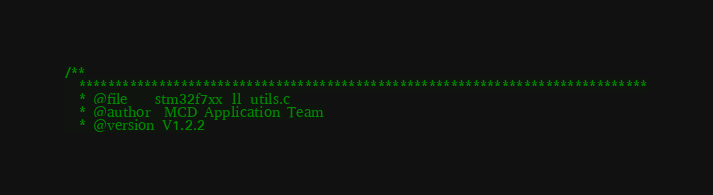Convert code to text. <code><loc_0><loc_0><loc_500><loc_500><_C_>/**
  ******************************************************************************
  * @file    stm32f7xx_ll_utils.c
  * @author  MCD Application Team
  * @version V1.2.2</code> 